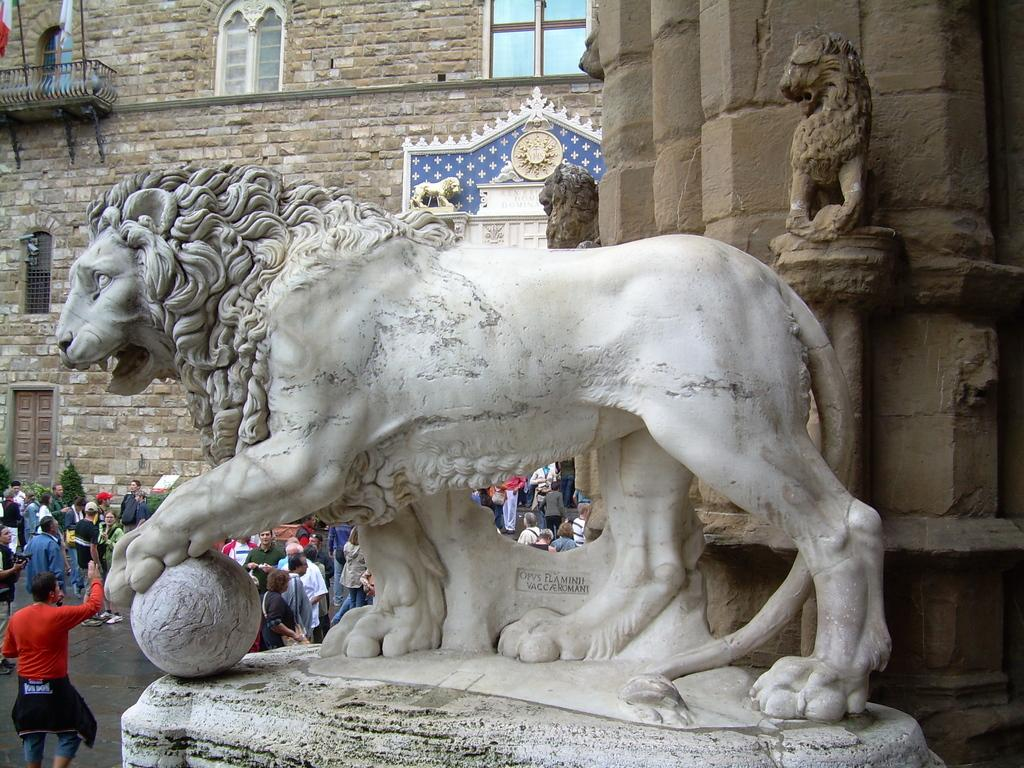What is the main subject of the image? There is a statue of an animal in the image. Where is the statue located? The statue is on a platform. What can be seen in the background of the image? There is a building, people, trees, and an unspecified object in the background of the image. Can you see an airport in the image? There is no mention of an airport in the image. 